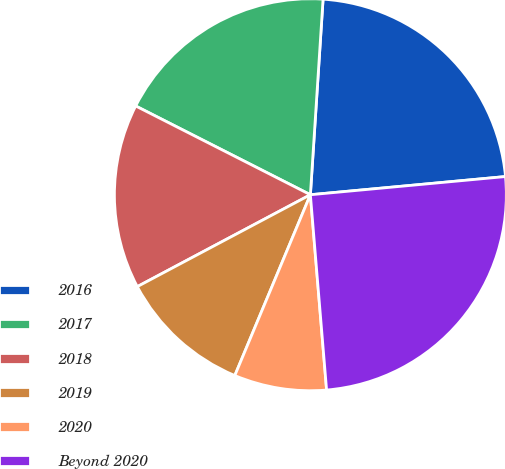Convert chart to OTSL. <chart><loc_0><loc_0><loc_500><loc_500><pie_chart><fcel>2016<fcel>2017<fcel>2018<fcel>2019<fcel>2020<fcel>Beyond 2020<nl><fcel>22.49%<fcel>18.55%<fcel>15.25%<fcel>10.93%<fcel>7.62%<fcel>25.16%<nl></chart> 